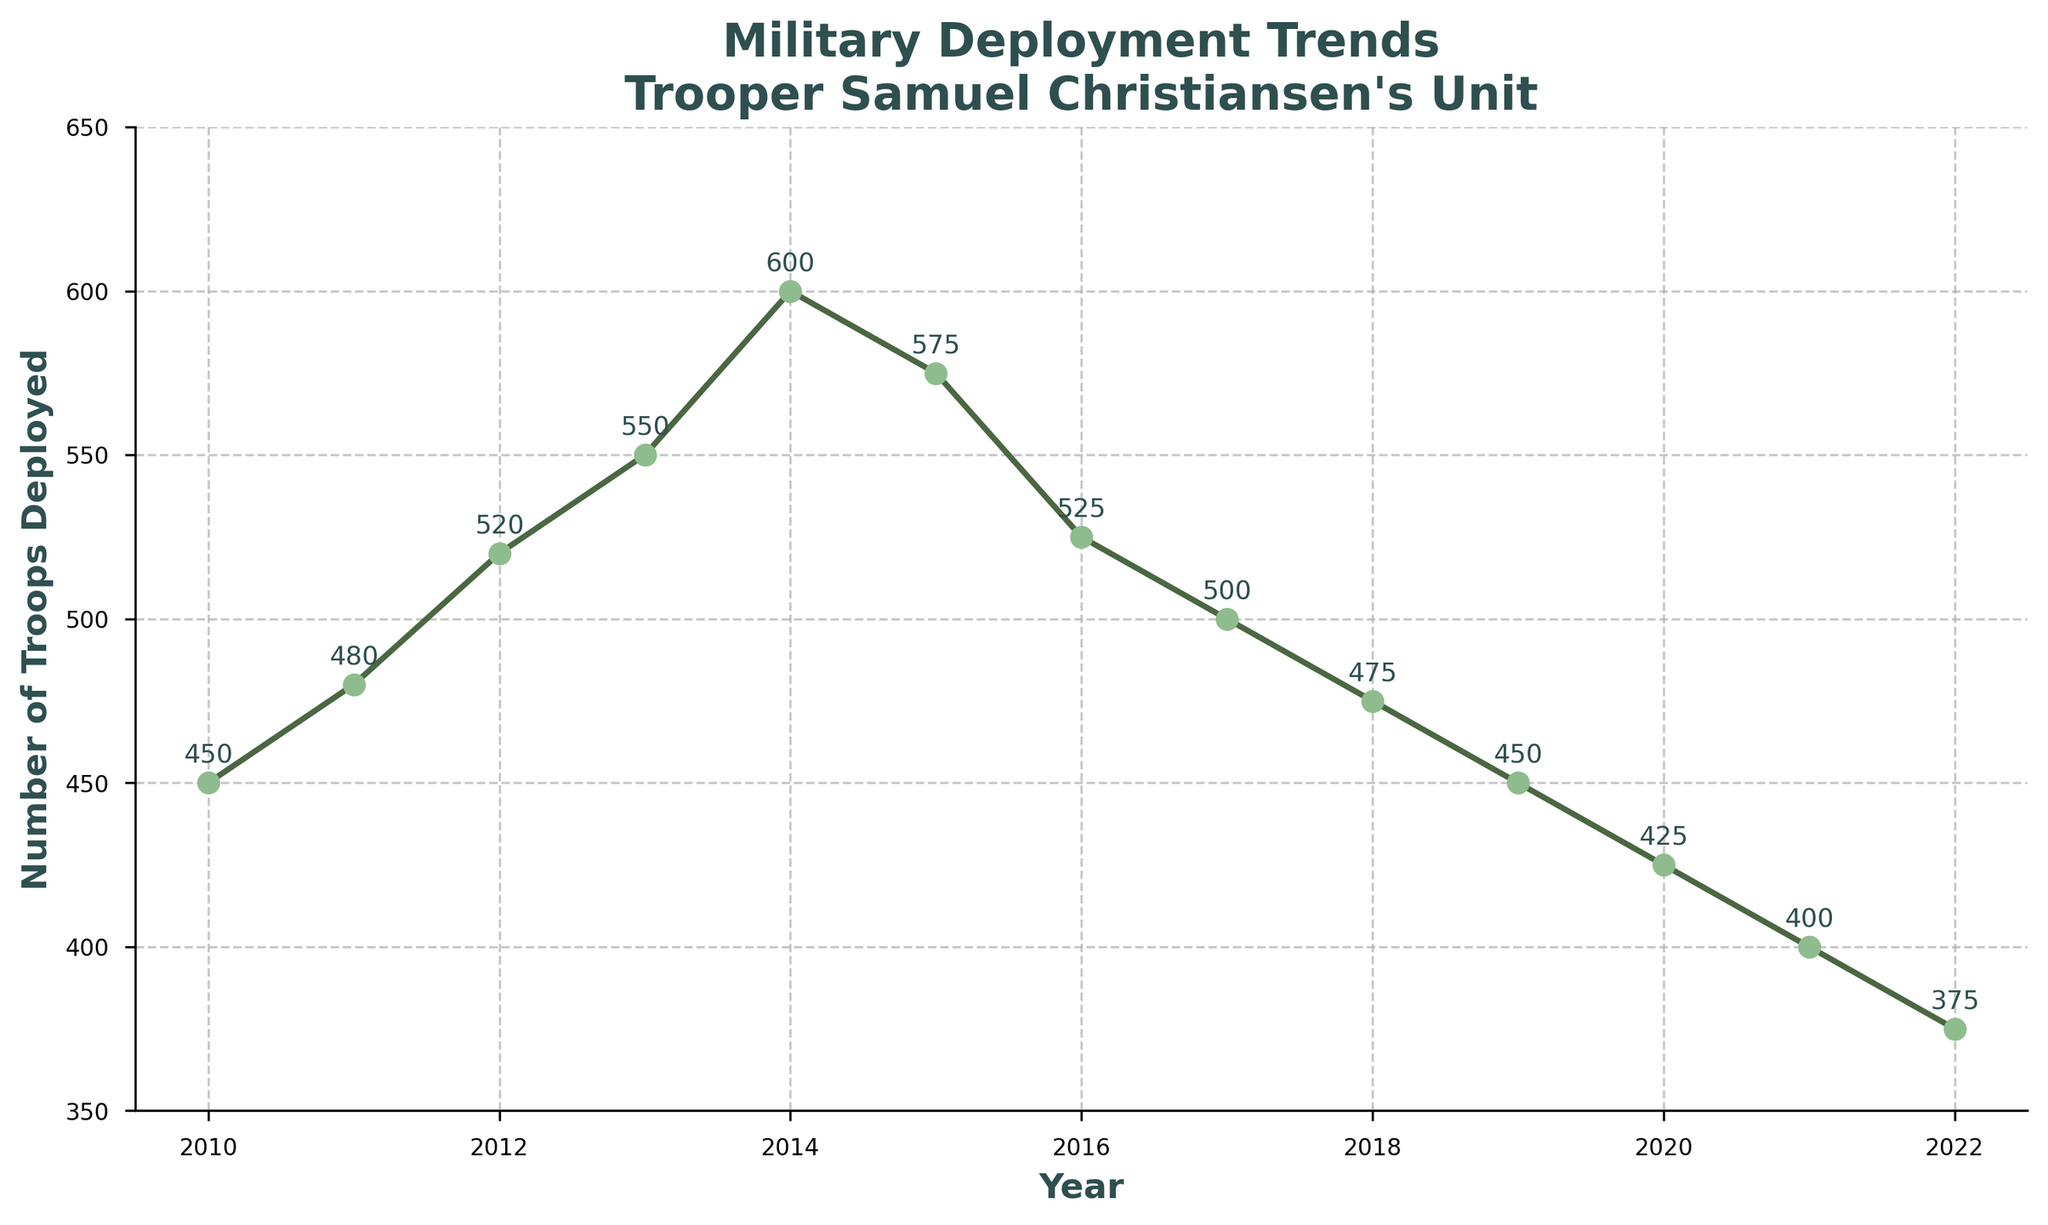How many more troops were deployed in 2014 compared to 2010? Subtract the number of troops deployed in 2010 from the number of troops deployed in 2014. 600 (2014) - 450 (2010) = 150
Answer: 150 Which year had the highest number of troops deployed? Look for the peak value in the graph. The highest point on the line corresponds to the year 2014 with 600 troops deployed.
Answer: 2014 Did the number of troops deployed increase or decrease between 2015 and 2016? By looking at the chart, observe the positions of 2015 and 2016. The value in 2015 is 575 and in 2016 it is 525. 525 is less than 575, so the number of troops decreased.
Answer: Decrease What's the average number of troops deployed from 2010 to 2012? Calculate the average of the values for 2010, 2011, and 2012. (450 + 480 + 520) / 3 = 1450 / 3 ≈ 483.33
Answer: ≈ 483.33 How many years experienced a decrease in troop deployment compared to the previous year? Count the instances where the current year's value is less than the previous year's value. 2015 to 2016, 2016 to 2017, 2017 to 2018, 2018 to 2019, 2019 to 2020, 2020 to 2021, 2021 to 2022 - total of 7 times.
Answer: 7 In which year was the number of troops deployed equal to 475? Identify the year where the number of troops deployed is exactly 475. The chart shows this value in the year 2018.
Answer: 2018 What was the trend in troop deployment from 2019 to 2022? Observe the graph from 2019 to 2022. The number of troops deployed shows a consistent downward trend.
Answer: Decrease By how much did troop deployment change from the peak year to the year 2022? Subtract the number of troops in 2022 from the peak value in 2014. 600 (peak in 2014) - 375 (2022) = 225
Answer: 225 Which year had the same number of troops deployed as 2020 and what was the number? Look for the year with the same deployment number as in 2020. The chart indicates that both 2019 and 2020 had 450 troops deployed.
Answer: 2019 